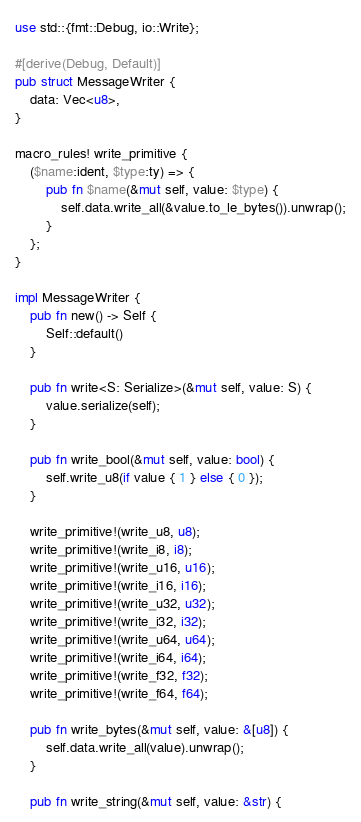Convert code to text. <code><loc_0><loc_0><loc_500><loc_500><_Rust_>use std::{fmt::Debug, io::Write};

#[derive(Debug, Default)]
pub struct MessageWriter {
    data: Vec<u8>,
}

macro_rules! write_primitive {
    ($name:ident, $type:ty) => {
        pub fn $name(&mut self, value: $type) {
            self.data.write_all(&value.to_le_bytes()).unwrap();
        }
    };
}

impl MessageWriter {
    pub fn new() -> Self {
        Self::default()
    }

    pub fn write<S: Serialize>(&mut self, value: S) {
        value.serialize(self);
    }

    pub fn write_bool(&mut self, value: bool) {
        self.write_u8(if value { 1 } else { 0 });
    }

    write_primitive!(write_u8, u8);
    write_primitive!(write_i8, i8);
    write_primitive!(write_u16, u16);
    write_primitive!(write_i16, i16);
    write_primitive!(write_u32, u32);
    write_primitive!(write_i32, i32);
    write_primitive!(write_u64, u64);
    write_primitive!(write_i64, i64);
    write_primitive!(write_f32, f32);
    write_primitive!(write_f64, f64);

    pub fn write_bytes(&mut self, value: &[u8]) {
        self.data.write_all(value).unwrap();
    }

    pub fn write_string(&mut self, value: &str) {</code> 